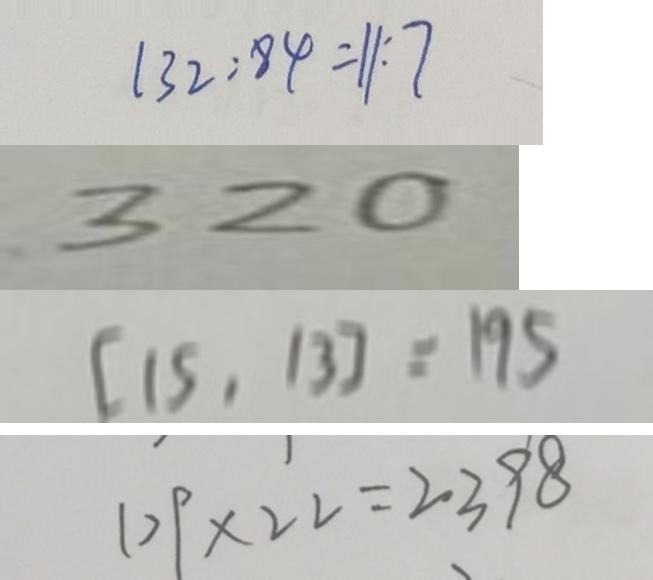<formula> <loc_0><loc_0><loc_500><loc_500>1 3 2 : 8 4 = 1 1 : 7 
 3 2 0 
 [ 1 5 , 1 3 ] = 1 9 5 
 1 0 9 \times 2 2 = 2 3 9 8</formula> 